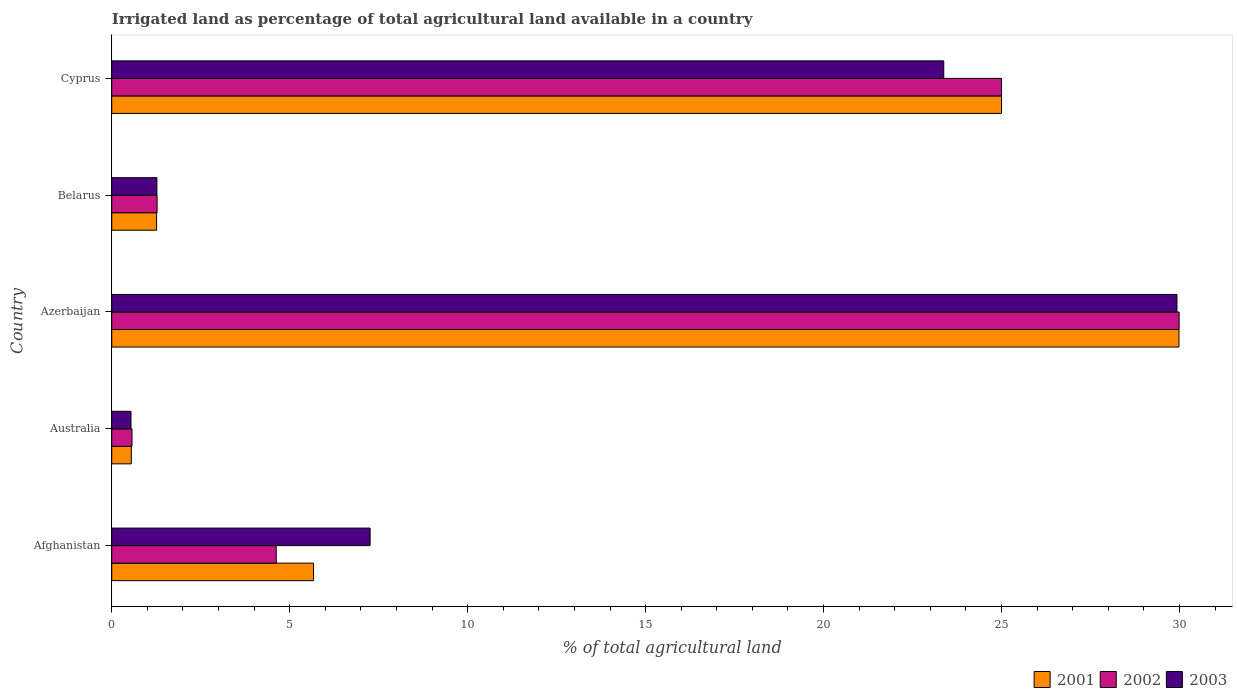How many different coloured bars are there?
Keep it short and to the point. 3. Are the number of bars per tick equal to the number of legend labels?
Offer a very short reply. Yes. Are the number of bars on each tick of the Y-axis equal?
Provide a succinct answer. Yes. How many bars are there on the 1st tick from the bottom?
Offer a very short reply. 3. What is the label of the 5th group of bars from the top?
Your response must be concise. Afghanistan. What is the percentage of irrigated land in 2003 in Azerbaijan?
Your answer should be very brief. 29.93. Across all countries, what is the maximum percentage of irrigated land in 2002?
Your answer should be very brief. 29.99. Across all countries, what is the minimum percentage of irrigated land in 2001?
Your answer should be compact. 0.55. In which country was the percentage of irrigated land in 2003 maximum?
Give a very brief answer. Azerbaijan. In which country was the percentage of irrigated land in 2002 minimum?
Make the answer very short. Australia. What is the total percentage of irrigated land in 2003 in the graph?
Give a very brief answer. 62.37. What is the difference between the percentage of irrigated land in 2003 in Australia and that in Belarus?
Give a very brief answer. -0.73. What is the difference between the percentage of irrigated land in 2001 in Cyprus and the percentage of irrigated land in 2003 in Australia?
Provide a succinct answer. 24.46. What is the average percentage of irrigated land in 2001 per country?
Offer a very short reply. 12.49. What is the difference between the percentage of irrigated land in 2001 and percentage of irrigated land in 2003 in Australia?
Your answer should be very brief. 0.01. What is the ratio of the percentage of irrigated land in 2003 in Azerbaijan to that in Belarus?
Offer a terse response. 23.59. What is the difference between the highest and the second highest percentage of irrigated land in 2001?
Your answer should be very brief. 4.99. What is the difference between the highest and the lowest percentage of irrigated land in 2003?
Your answer should be compact. 29.39. In how many countries, is the percentage of irrigated land in 2003 greater than the average percentage of irrigated land in 2003 taken over all countries?
Offer a terse response. 2. Is the sum of the percentage of irrigated land in 2002 in Australia and Cyprus greater than the maximum percentage of irrigated land in 2001 across all countries?
Offer a very short reply. No. How many bars are there?
Your answer should be very brief. 15. What is the difference between two consecutive major ticks on the X-axis?
Your answer should be compact. 5. Are the values on the major ticks of X-axis written in scientific E-notation?
Your response must be concise. No. Does the graph contain any zero values?
Ensure brevity in your answer.  No. Where does the legend appear in the graph?
Give a very brief answer. Bottom right. How many legend labels are there?
Provide a succinct answer. 3. What is the title of the graph?
Keep it short and to the point. Irrigated land as percentage of total agricultural land available in a country. Does "2013" appear as one of the legend labels in the graph?
Your answer should be compact. No. What is the label or title of the X-axis?
Provide a succinct answer. % of total agricultural land. What is the label or title of the Y-axis?
Your answer should be very brief. Country. What is the % of total agricultural land of 2001 in Afghanistan?
Make the answer very short. 5.67. What is the % of total agricultural land in 2002 in Afghanistan?
Your answer should be very brief. 4.62. What is the % of total agricultural land in 2003 in Afghanistan?
Give a very brief answer. 7.26. What is the % of total agricultural land in 2001 in Australia?
Your answer should be very brief. 0.55. What is the % of total agricultural land in 2002 in Australia?
Provide a succinct answer. 0.57. What is the % of total agricultural land of 2003 in Australia?
Give a very brief answer. 0.54. What is the % of total agricultural land of 2001 in Azerbaijan?
Give a very brief answer. 29.99. What is the % of total agricultural land in 2002 in Azerbaijan?
Offer a very short reply. 29.99. What is the % of total agricultural land of 2003 in Azerbaijan?
Provide a short and direct response. 29.93. What is the % of total agricultural land in 2001 in Belarus?
Ensure brevity in your answer.  1.26. What is the % of total agricultural land in 2002 in Belarus?
Keep it short and to the point. 1.27. What is the % of total agricultural land of 2003 in Belarus?
Provide a short and direct response. 1.27. What is the % of total agricultural land of 2001 in Cyprus?
Provide a succinct answer. 25. What is the % of total agricultural land of 2002 in Cyprus?
Ensure brevity in your answer.  25. What is the % of total agricultural land of 2003 in Cyprus?
Your answer should be very brief. 23.38. Across all countries, what is the maximum % of total agricultural land in 2001?
Your answer should be compact. 29.99. Across all countries, what is the maximum % of total agricultural land in 2002?
Make the answer very short. 29.99. Across all countries, what is the maximum % of total agricultural land of 2003?
Keep it short and to the point. 29.93. Across all countries, what is the minimum % of total agricultural land of 2001?
Ensure brevity in your answer.  0.55. Across all countries, what is the minimum % of total agricultural land in 2002?
Your answer should be compact. 0.57. Across all countries, what is the minimum % of total agricultural land in 2003?
Keep it short and to the point. 0.54. What is the total % of total agricultural land in 2001 in the graph?
Make the answer very short. 62.46. What is the total % of total agricultural land in 2002 in the graph?
Provide a succinct answer. 61.46. What is the total % of total agricultural land in 2003 in the graph?
Make the answer very short. 62.37. What is the difference between the % of total agricultural land of 2001 in Afghanistan and that in Australia?
Ensure brevity in your answer.  5.12. What is the difference between the % of total agricultural land of 2002 in Afghanistan and that in Australia?
Your answer should be very brief. 4.05. What is the difference between the % of total agricultural land of 2003 in Afghanistan and that in Australia?
Offer a very short reply. 6.72. What is the difference between the % of total agricultural land in 2001 in Afghanistan and that in Azerbaijan?
Your response must be concise. -24.32. What is the difference between the % of total agricultural land in 2002 in Afghanistan and that in Azerbaijan?
Offer a terse response. -25.37. What is the difference between the % of total agricultural land in 2003 in Afghanistan and that in Azerbaijan?
Provide a succinct answer. -22.67. What is the difference between the % of total agricultural land in 2001 in Afghanistan and that in Belarus?
Provide a short and direct response. 4.41. What is the difference between the % of total agricultural land of 2002 in Afghanistan and that in Belarus?
Your answer should be very brief. 3.35. What is the difference between the % of total agricultural land in 2003 in Afghanistan and that in Belarus?
Your response must be concise. 5.99. What is the difference between the % of total agricultural land of 2001 in Afghanistan and that in Cyprus?
Give a very brief answer. -19.33. What is the difference between the % of total agricultural land of 2002 in Afghanistan and that in Cyprus?
Provide a short and direct response. -20.38. What is the difference between the % of total agricultural land of 2003 in Afghanistan and that in Cyprus?
Your answer should be very brief. -16.12. What is the difference between the % of total agricultural land in 2001 in Australia and that in Azerbaijan?
Provide a succinct answer. -29.44. What is the difference between the % of total agricultural land in 2002 in Australia and that in Azerbaijan?
Give a very brief answer. -29.42. What is the difference between the % of total agricultural land of 2003 in Australia and that in Azerbaijan?
Make the answer very short. -29.39. What is the difference between the % of total agricultural land in 2001 in Australia and that in Belarus?
Your response must be concise. -0.71. What is the difference between the % of total agricultural land of 2002 in Australia and that in Belarus?
Provide a succinct answer. -0.7. What is the difference between the % of total agricultural land of 2003 in Australia and that in Belarus?
Provide a succinct answer. -0.73. What is the difference between the % of total agricultural land of 2001 in Australia and that in Cyprus?
Make the answer very short. -24.45. What is the difference between the % of total agricultural land of 2002 in Australia and that in Cyprus?
Provide a succinct answer. -24.43. What is the difference between the % of total agricultural land in 2003 in Australia and that in Cyprus?
Your answer should be compact. -22.84. What is the difference between the % of total agricultural land in 2001 in Azerbaijan and that in Belarus?
Offer a terse response. 28.73. What is the difference between the % of total agricultural land of 2002 in Azerbaijan and that in Belarus?
Your answer should be compact. 28.72. What is the difference between the % of total agricultural land of 2003 in Azerbaijan and that in Belarus?
Your response must be concise. 28.66. What is the difference between the % of total agricultural land of 2001 in Azerbaijan and that in Cyprus?
Make the answer very short. 4.99. What is the difference between the % of total agricultural land of 2002 in Azerbaijan and that in Cyprus?
Provide a short and direct response. 4.99. What is the difference between the % of total agricultural land of 2003 in Azerbaijan and that in Cyprus?
Offer a very short reply. 6.55. What is the difference between the % of total agricultural land of 2001 in Belarus and that in Cyprus?
Offer a terse response. -23.74. What is the difference between the % of total agricultural land in 2002 in Belarus and that in Cyprus?
Offer a very short reply. -23.73. What is the difference between the % of total agricultural land in 2003 in Belarus and that in Cyprus?
Ensure brevity in your answer.  -22.11. What is the difference between the % of total agricultural land in 2001 in Afghanistan and the % of total agricultural land in 2002 in Australia?
Ensure brevity in your answer.  5.1. What is the difference between the % of total agricultural land in 2001 in Afghanistan and the % of total agricultural land in 2003 in Australia?
Keep it short and to the point. 5.13. What is the difference between the % of total agricultural land in 2002 in Afghanistan and the % of total agricultural land in 2003 in Australia?
Offer a very short reply. 4.08. What is the difference between the % of total agricultural land of 2001 in Afghanistan and the % of total agricultural land of 2002 in Azerbaijan?
Offer a very short reply. -24.32. What is the difference between the % of total agricultural land of 2001 in Afghanistan and the % of total agricultural land of 2003 in Azerbaijan?
Keep it short and to the point. -24.26. What is the difference between the % of total agricultural land of 2002 in Afghanistan and the % of total agricultural land of 2003 in Azerbaijan?
Keep it short and to the point. -25.31. What is the difference between the % of total agricultural land in 2001 in Afghanistan and the % of total agricultural land in 2002 in Belarus?
Your answer should be very brief. 4.39. What is the difference between the % of total agricultural land of 2001 in Afghanistan and the % of total agricultural land of 2003 in Belarus?
Give a very brief answer. 4.4. What is the difference between the % of total agricultural land of 2002 in Afghanistan and the % of total agricultural land of 2003 in Belarus?
Keep it short and to the point. 3.35. What is the difference between the % of total agricultural land in 2001 in Afghanistan and the % of total agricultural land in 2002 in Cyprus?
Ensure brevity in your answer.  -19.33. What is the difference between the % of total agricultural land of 2001 in Afghanistan and the % of total agricultural land of 2003 in Cyprus?
Give a very brief answer. -17.71. What is the difference between the % of total agricultural land in 2002 in Afghanistan and the % of total agricultural land in 2003 in Cyprus?
Give a very brief answer. -18.75. What is the difference between the % of total agricultural land in 2001 in Australia and the % of total agricultural land in 2002 in Azerbaijan?
Provide a succinct answer. -29.44. What is the difference between the % of total agricultural land of 2001 in Australia and the % of total agricultural land of 2003 in Azerbaijan?
Provide a short and direct response. -29.38. What is the difference between the % of total agricultural land of 2002 in Australia and the % of total agricultural land of 2003 in Azerbaijan?
Offer a very short reply. -29.36. What is the difference between the % of total agricultural land in 2001 in Australia and the % of total agricultural land in 2002 in Belarus?
Your answer should be very brief. -0.72. What is the difference between the % of total agricultural land in 2001 in Australia and the % of total agricultural land in 2003 in Belarus?
Offer a very short reply. -0.72. What is the difference between the % of total agricultural land in 2002 in Australia and the % of total agricultural land in 2003 in Belarus?
Your answer should be very brief. -0.7. What is the difference between the % of total agricultural land of 2001 in Australia and the % of total agricultural land of 2002 in Cyprus?
Offer a terse response. -24.45. What is the difference between the % of total agricultural land in 2001 in Australia and the % of total agricultural land in 2003 in Cyprus?
Ensure brevity in your answer.  -22.83. What is the difference between the % of total agricultural land of 2002 in Australia and the % of total agricultural land of 2003 in Cyprus?
Ensure brevity in your answer.  -22.81. What is the difference between the % of total agricultural land of 2001 in Azerbaijan and the % of total agricultural land of 2002 in Belarus?
Your answer should be compact. 28.71. What is the difference between the % of total agricultural land of 2001 in Azerbaijan and the % of total agricultural land of 2003 in Belarus?
Keep it short and to the point. 28.72. What is the difference between the % of total agricultural land in 2002 in Azerbaijan and the % of total agricultural land in 2003 in Belarus?
Offer a very short reply. 28.72. What is the difference between the % of total agricultural land in 2001 in Azerbaijan and the % of total agricultural land in 2002 in Cyprus?
Your answer should be very brief. 4.99. What is the difference between the % of total agricultural land of 2001 in Azerbaijan and the % of total agricultural land of 2003 in Cyprus?
Provide a succinct answer. 6.61. What is the difference between the % of total agricultural land of 2002 in Azerbaijan and the % of total agricultural land of 2003 in Cyprus?
Ensure brevity in your answer.  6.61. What is the difference between the % of total agricultural land in 2001 in Belarus and the % of total agricultural land in 2002 in Cyprus?
Provide a short and direct response. -23.74. What is the difference between the % of total agricultural land of 2001 in Belarus and the % of total agricultural land of 2003 in Cyprus?
Keep it short and to the point. -22.12. What is the difference between the % of total agricultural land in 2002 in Belarus and the % of total agricultural land in 2003 in Cyprus?
Offer a terse response. -22.1. What is the average % of total agricultural land in 2001 per country?
Provide a succinct answer. 12.49. What is the average % of total agricultural land of 2002 per country?
Offer a very short reply. 12.29. What is the average % of total agricultural land of 2003 per country?
Keep it short and to the point. 12.47. What is the difference between the % of total agricultural land in 2001 and % of total agricultural land in 2002 in Afghanistan?
Your answer should be compact. 1.05. What is the difference between the % of total agricultural land in 2001 and % of total agricultural land in 2003 in Afghanistan?
Offer a terse response. -1.59. What is the difference between the % of total agricultural land in 2002 and % of total agricultural land in 2003 in Afghanistan?
Offer a very short reply. -2.64. What is the difference between the % of total agricultural land of 2001 and % of total agricultural land of 2002 in Australia?
Make the answer very short. -0.02. What is the difference between the % of total agricultural land in 2001 and % of total agricultural land in 2003 in Australia?
Offer a very short reply. 0.01. What is the difference between the % of total agricultural land of 2002 and % of total agricultural land of 2003 in Australia?
Your answer should be compact. 0.03. What is the difference between the % of total agricultural land of 2001 and % of total agricultural land of 2002 in Azerbaijan?
Your response must be concise. -0. What is the difference between the % of total agricultural land in 2001 and % of total agricultural land in 2003 in Azerbaijan?
Offer a terse response. 0.06. What is the difference between the % of total agricultural land of 2002 and % of total agricultural land of 2003 in Azerbaijan?
Give a very brief answer. 0.06. What is the difference between the % of total agricultural land of 2001 and % of total agricultural land of 2002 in Belarus?
Offer a terse response. -0.01. What is the difference between the % of total agricultural land of 2001 and % of total agricultural land of 2003 in Belarus?
Give a very brief answer. -0.01. What is the difference between the % of total agricultural land of 2002 and % of total agricultural land of 2003 in Belarus?
Provide a succinct answer. 0.01. What is the difference between the % of total agricultural land in 2001 and % of total agricultural land in 2002 in Cyprus?
Offer a terse response. 0. What is the difference between the % of total agricultural land in 2001 and % of total agricultural land in 2003 in Cyprus?
Keep it short and to the point. 1.62. What is the difference between the % of total agricultural land of 2002 and % of total agricultural land of 2003 in Cyprus?
Offer a terse response. 1.62. What is the ratio of the % of total agricultural land in 2001 in Afghanistan to that in Australia?
Provide a succinct answer. 10.31. What is the ratio of the % of total agricultural land of 2002 in Afghanistan to that in Australia?
Give a very brief answer. 8.12. What is the ratio of the % of total agricultural land in 2003 in Afghanistan to that in Australia?
Give a very brief answer. 13.42. What is the ratio of the % of total agricultural land in 2001 in Afghanistan to that in Azerbaijan?
Provide a short and direct response. 0.19. What is the ratio of the % of total agricultural land of 2002 in Afghanistan to that in Azerbaijan?
Give a very brief answer. 0.15. What is the ratio of the % of total agricultural land of 2003 in Afghanistan to that in Azerbaijan?
Provide a succinct answer. 0.24. What is the ratio of the % of total agricultural land of 2001 in Afghanistan to that in Belarus?
Ensure brevity in your answer.  4.5. What is the ratio of the % of total agricultural land in 2002 in Afghanistan to that in Belarus?
Make the answer very short. 3.63. What is the ratio of the % of total agricultural land in 2003 in Afghanistan to that in Belarus?
Give a very brief answer. 5.72. What is the ratio of the % of total agricultural land in 2001 in Afghanistan to that in Cyprus?
Provide a short and direct response. 0.23. What is the ratio of the % of total agricultural land of 2002 in Afghanistan to that in Cyprus?
Your response must be concise. 0.18. What is the ratio of the % of total agricultural land of 2003 in Afghanistan to that in Cyprus?
Keep it short and to the point. 0.31. What is the ratio of the % of total agricultural land in 2001 in Australia to that in Azerbaijan?
Your answer should be very brief. 0.02. What is the ratio of the % of total agricultural land in 2002 in Australia to that in Azerbaijan?
Ensure brevity in your answer.  0.02. What is the ratio of the % of total agricultural land in 2003 in Australia to that in Azerbaijan?
Provide a short and direct response. 0.02. What is the ratio of the % of total agricultural land of 2001 in Australia to that in Belarus?
Offer a terse response. 0.44. What is the ratio of the % of total agricultural land in 2002 in Australia to that in Belarus?
Ensure brevity in your answer.  0.45. What is the ratio of the % of total agricultural land of 2003 in Australia to that in Belarus?
Your answer should be very brief. 0.43. What is the ratio of the % of total agricultural land in 2001 in Australia to that in Cyprus?
Make the answer very short. 0.02. What is the ratio of the % of total agricultural land in 2002 in Australia to that in Cyprus?
Your response must be concise. 0.02. What is the ratio of the % of total agricultural land of 2003 in Australia to that in Cyprus?
Provide a short and direct response. 0.02. What is the ratio of the % of total agricultural land in 2001 in Azerbaijan to that in Belarus?
Give a very brief answer. 23.8. What is the ratio of the % of total agricultural land of 2002 in Azerbaijan to that in Belarus?
Offer a terse response. 23.54. What is the ratio of the % of total agricultural land in 2003 in Azerbaijan to that in Belarus?
Give a very brief answer. 23.59. What is the ratio of the % of total agricultural land in 2001 in Azerbaijan to that in Cyprus?
Offer a very short reply. 1.2. What is the ratio of the % of total agricultural land in 2002 in Azerbaijan to that in Cyprus?
Provide a short and direct response. 1.2. What is the ratio of the % of total agricultural land in 2003 in Azerbaijan to that in Cyprus?
Provide a short and direct response. 1.28. What is the ratio of the % of total agricultural land of 2001 in Belarus to that in Cyprus?
Ensure brevity in your answer.  0.05. What is the ratio of the % of total agricultural land in 2002 in Belarus to that in Cyprus?
Keep it short and to the point. 0.05. What is the ratio of the % of total agricultural land in 2003 in Belarus to that in Cyprus?
Make the answer very short. 0.05. What is the difference between the highest and the second highest % of total agricultural land of 2001?
Your answer should be very brief. 4.99. What is the difference between the highest and the second highest % of total agricultural land in 2002?
Ensure brevity in your answer.  4.99. What is the difference between the highest and the second highest % of total agricultural land of 2003?
Provide a short and direct response. 6.55. What is the difference between the highest and the lowest % of total agricultural land in 2001?
Offer a very short reply. 29.44. What is the difference between the highest and the lowest % of total agricultural land of 2002?
Provide a succinct answer. 29.42. What is the difference between the highest and the lowest % of total agricultural land in 2003?
Provide a succinct answer. 29.39. 